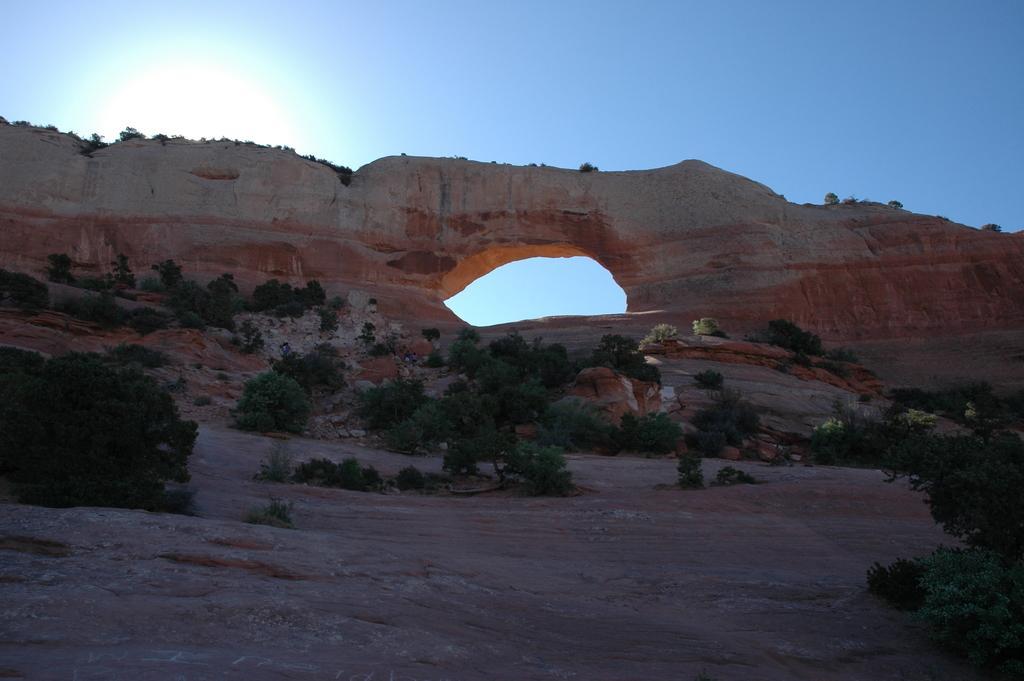Can you describe this image briefly? In the foreground of this image, there is a hole in the rock and on bottom of the picture, there are plants on the surface and on the top, there is a shade of the sun and the sky. 